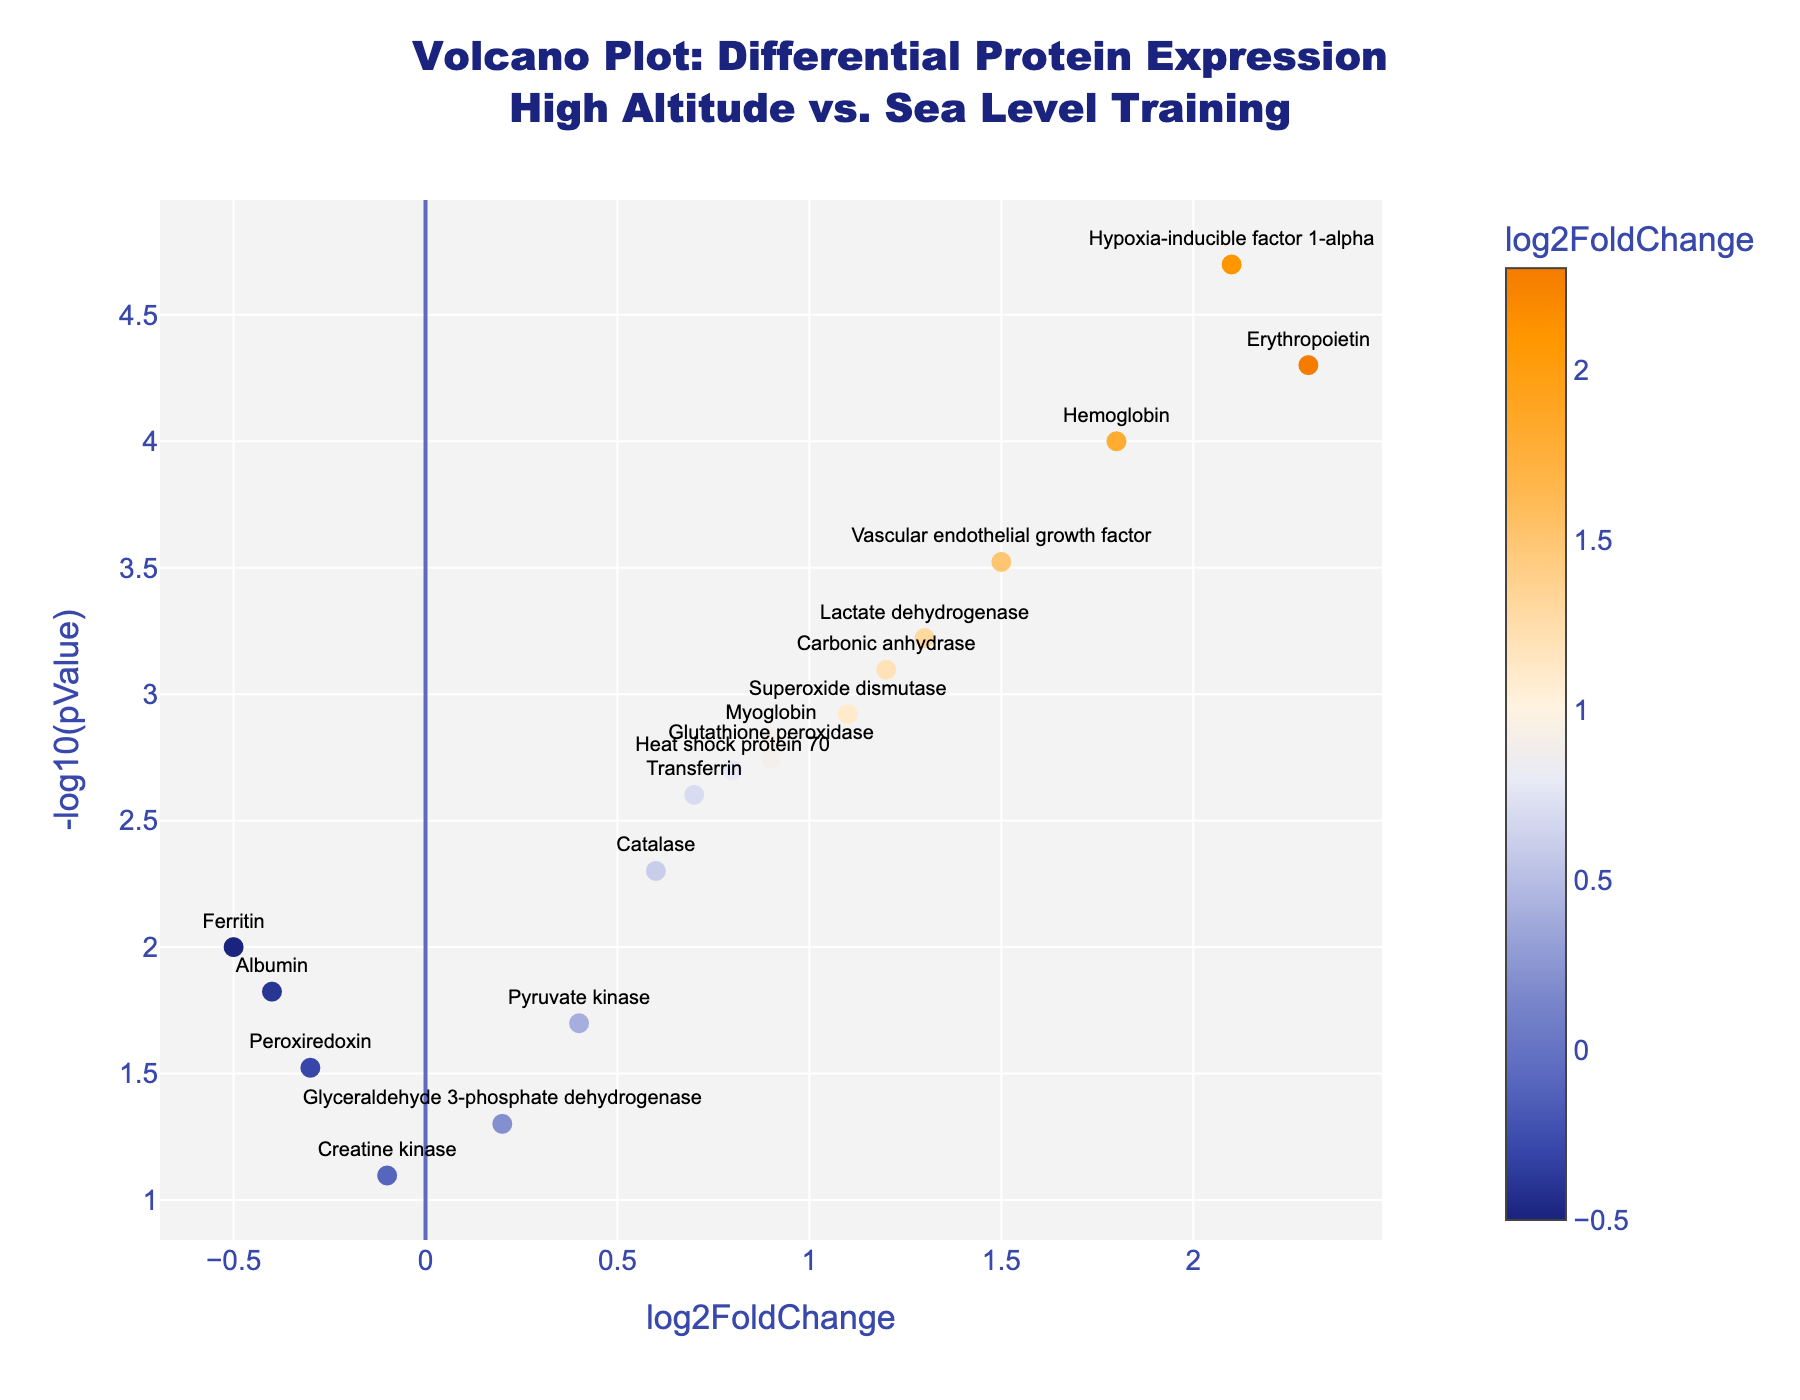What's the title of the Volcano Plot? The title of the plot is prominently displayed at the top and reads "Volcano Plot: Differential Protein Expression<br>High Altitude vs. Sea Level Training."
Answer: Volcano Plot: Differential Protein Expression<br>High Altitude vs. Sea Level Training How many proteins are represented in the plot? By counting the number of unique data points, we can see that there are 18 proteins displayed in the plot.
Answer: 18 Which protein has the highest log2FoldChange value? By looking at the x-axis (log2FoldChange) and identifying the highest value, we can see that Erythropoietin has the highest log2FoldChange of 2.3.
Answer: Erythropoietin Which protein has the lowest p-value? By examining the y-axis values in terms of -log10(pValue), the protein with the highest value on this axis has the lowest p-value, which is Hypoxia-inducible factor 1-alpha.
Answer: Hypoxia-inducible factor 1-alpha What is the log2FoldChange value for Hemoglobin? The log2FoldChange value for Hemoglobin can be read directly from the plotted point associated with Hemoglobin, which is 1.8.
Answer: 1.8 Are there any proteins with a negative log2FoldChange? If so, name one. By scanning the x-axis values for negative log2FoldChange, we can identify several proteins including Ferritin.
Answer: Ferritin What is the relationship between the log2FoldChange and -log10(pValue) for the protein Superoxide dismutase? The data point for Superoxide dismutase shows a log2FoldChange of 1.1 and a -log10(pValue) of around 2.92, which translates to a pValue of approximately 0.0012.
Answer: log2FoldChange of 1.1 and -log10(pValue) of 2.92 Which proteins have a log2FoldChange greater than 1.5 and how significant are their p-values? Proteins with log2FoldChange greater than 1.5 are Erythropoietin and Hypoxia-inducible factor 1-alpha, both with highly significant p-values (very high -log10(pValue) indicating much lower p-values).
Answer: Erythropoietin and Hypoxia-inducible factor 1-alpha with highly significant p-values Which protein has the lowest -log10(pValue) and what does that imply about its p-value? Glyceraldehyde 3-phosphate dehydrogenase has the lowest -log10(pValue), which is a value of approximately 1.30, implying it has the highest p-value around 0.05 among the plotted proteins.
Answer: Glyceraldehyde 3-phosphate dehydrogenase What can you infer about proteins with log2FoldChange values less than 0? Proteins with log2FoldChange values less than 0, such as Ferritin, Peroxiredoxin, Creatine kinase, and Albumin, are downregulated in athletes training at high altitudes compared to sea level.
Answer: They are downregulated 